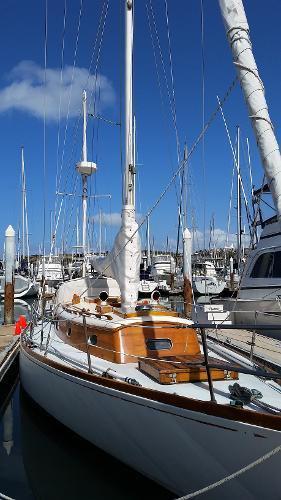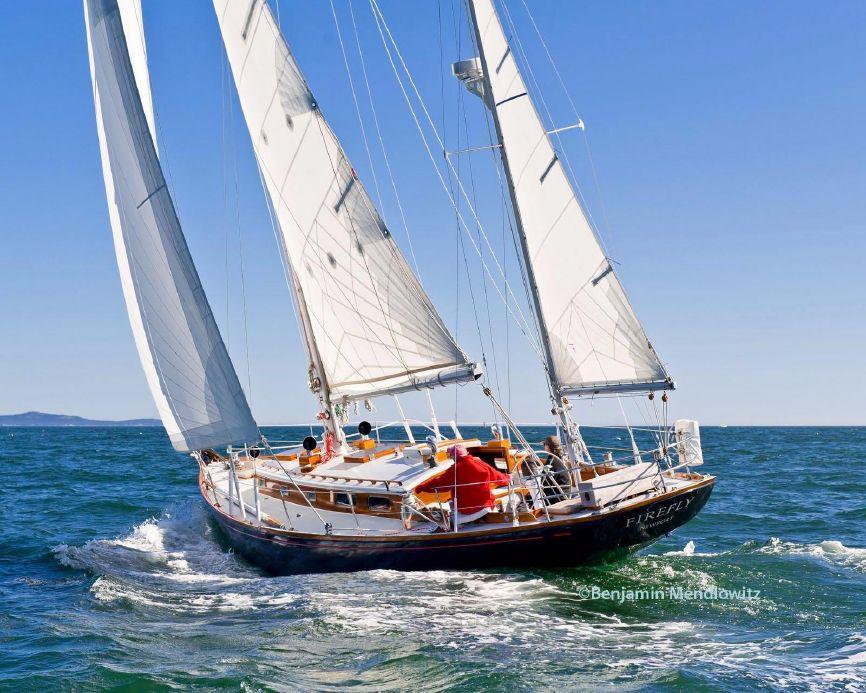The first image is the image on the left, the second image is the image on the right. Analyze the images presented: Is the assertion "One of the images contains a single sailboat with three sails" valid? Answer yes or no. Yes. 